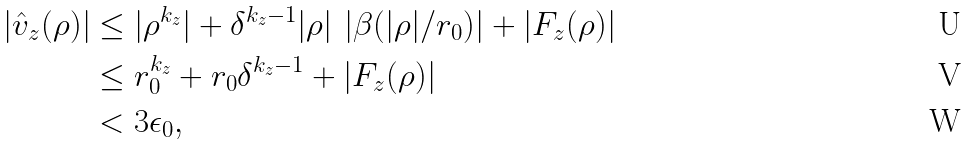Convert formula to latex. <formula><loc_0><loc_0><loc_500><loc_500>| \hat { v } _ { z } ( \rho ) | & \leq | \rho ^ { k _ { z } } | + \delta ^ { k _ { z } - 1 } | \rho | \, \left | \beta ( | \rho | / r _ { 0 } ) \right | + | F _ { z } ( \rho ) | \\ & \leq r _ { 0 } ^ { k _ { z } } + r _ { 0 } \delta ^ { k _ { z } - 1 } + | F _ { z } ( \rho ) | \\ & < 3 \epsilon _ { 0 } ,</formula> 